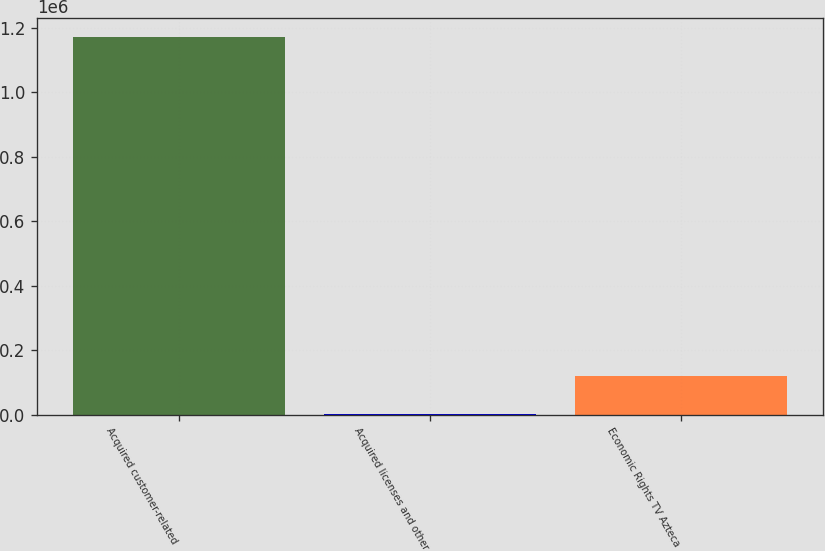Convert chart. <chart><loc_0><loc_0><loc_500><loc_500><bar_chart><fcel>Acquired customer-related<fcel>Acquired licenses and other<fcel>Economic Rights TV Azteca<nl><fcel>1.17024e+06<fcel>2297<fcel>119091<nl></chart> 